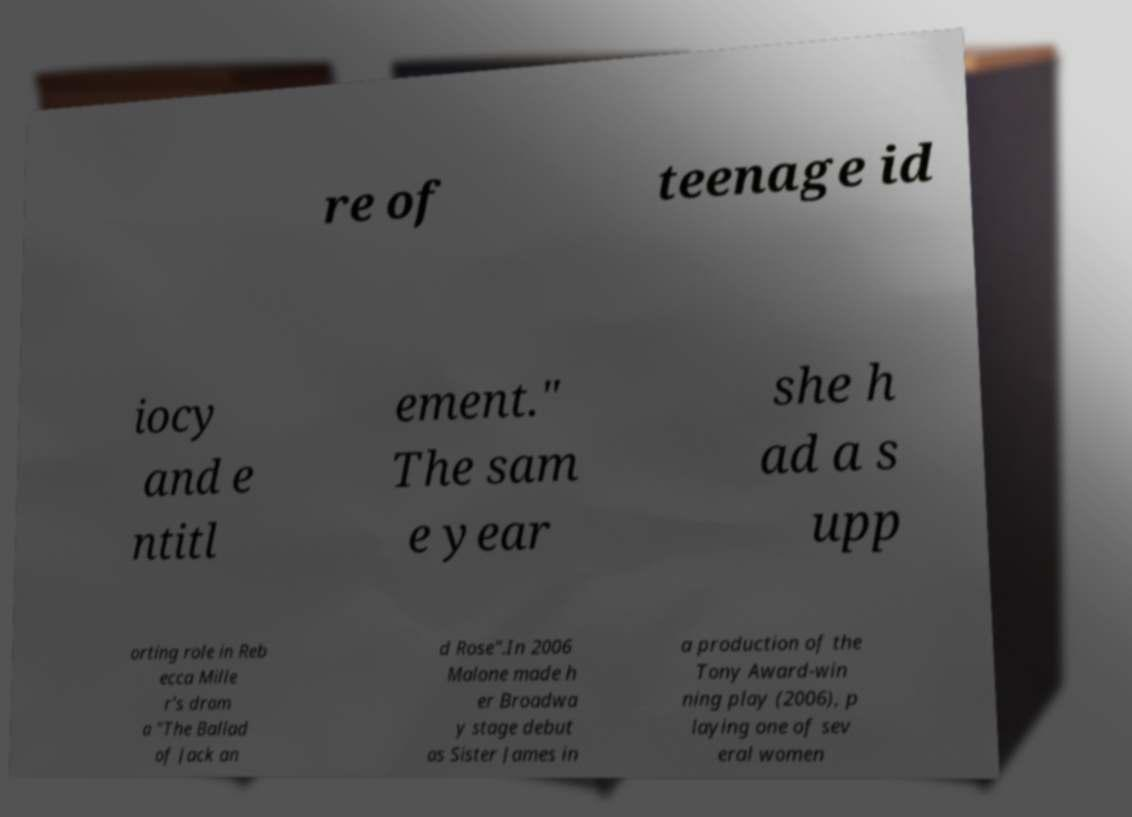Please read and relay the text visible in this image. What does it say? re of teenage id iocy and e ntitl ement." The sam e year she h ad a s upp orting role in Reb ecca Mille r's dram a "The Ballad of Jack an d Rose".In 2006 Malone made h er Broadwa y stage debut as Sister James in a production of the Tony Award-win ning play (2006), p laying one of sev eral women 